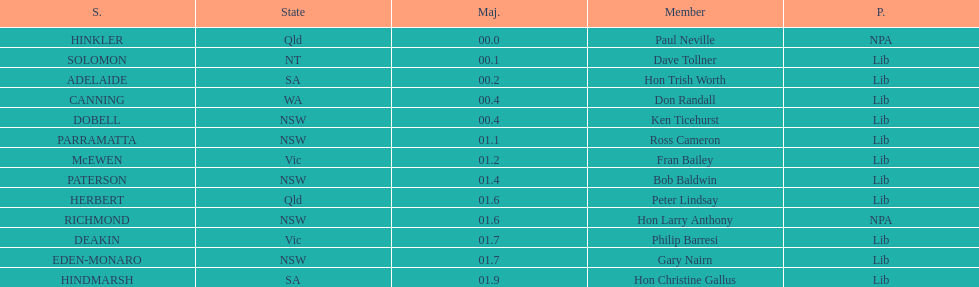Was fran bailey from vic or wa? Vic. 